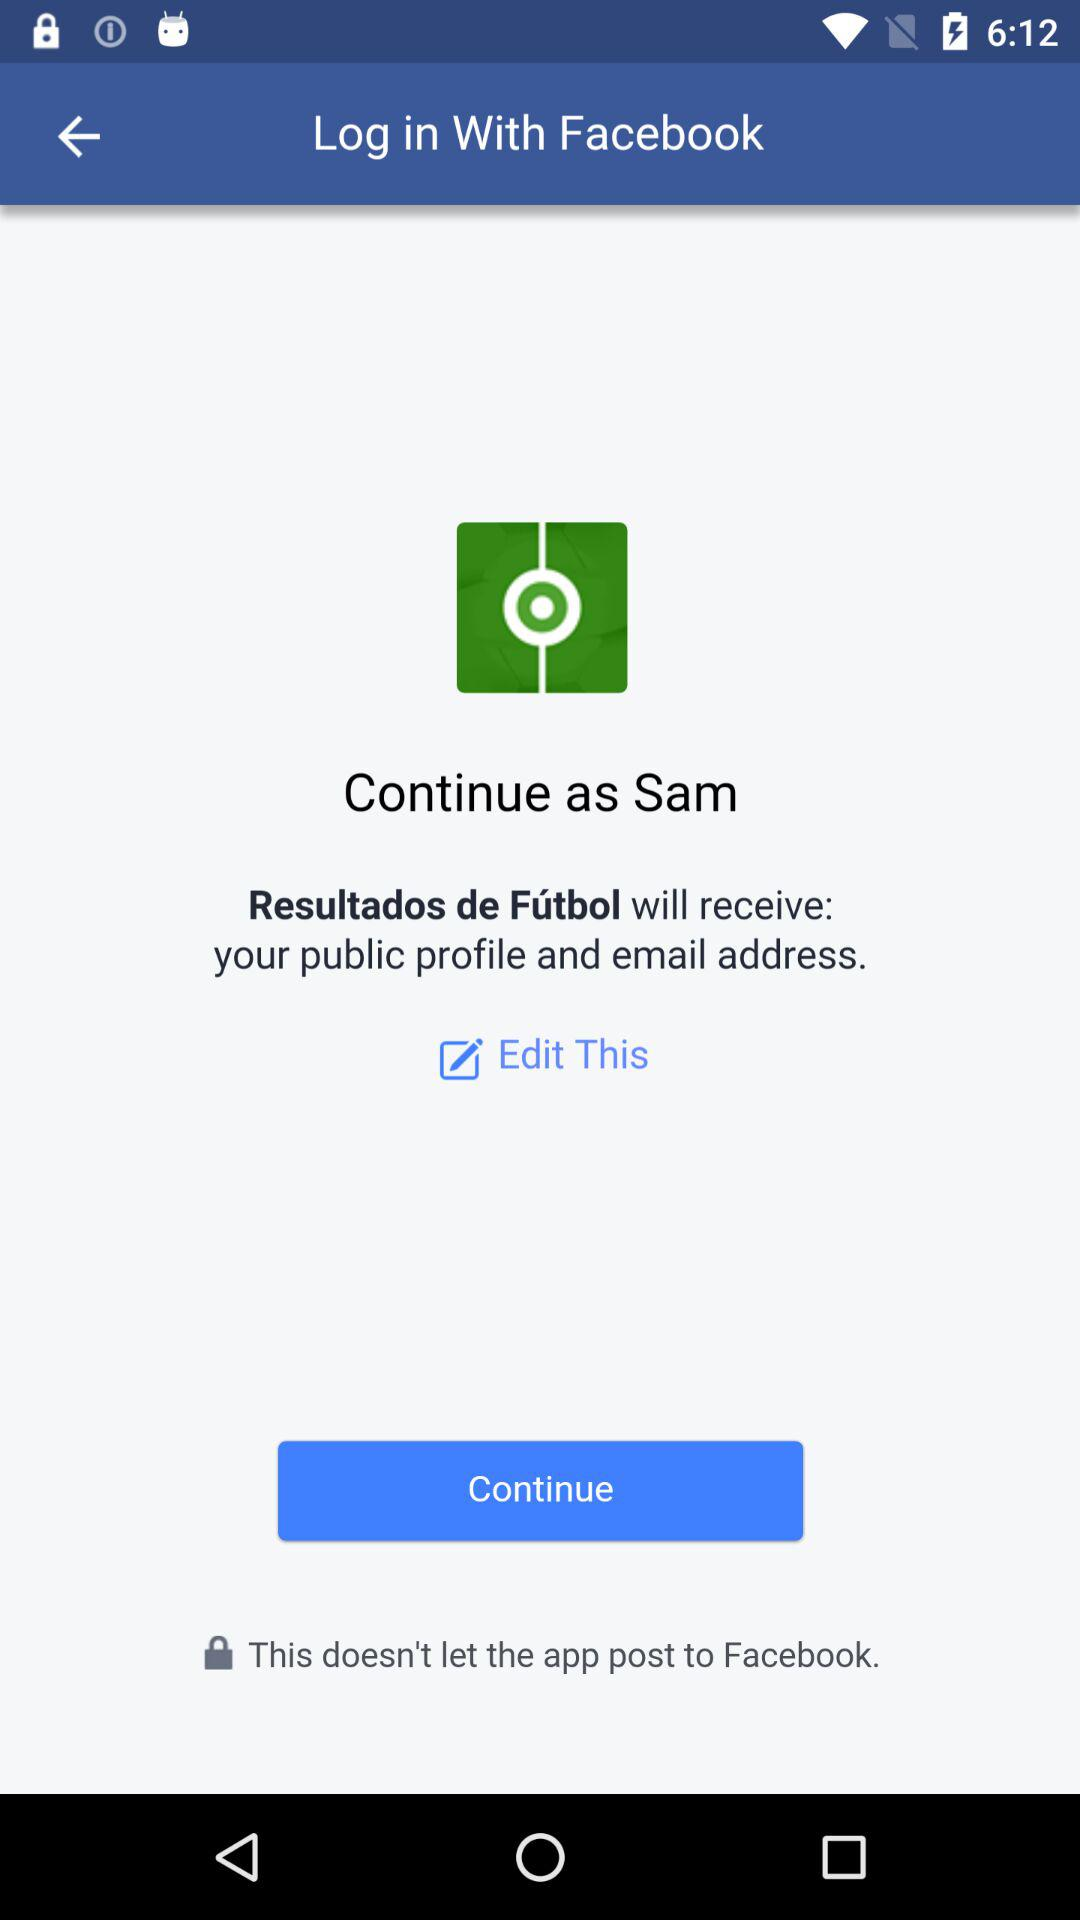What is the user name? The user name is "Sam". 